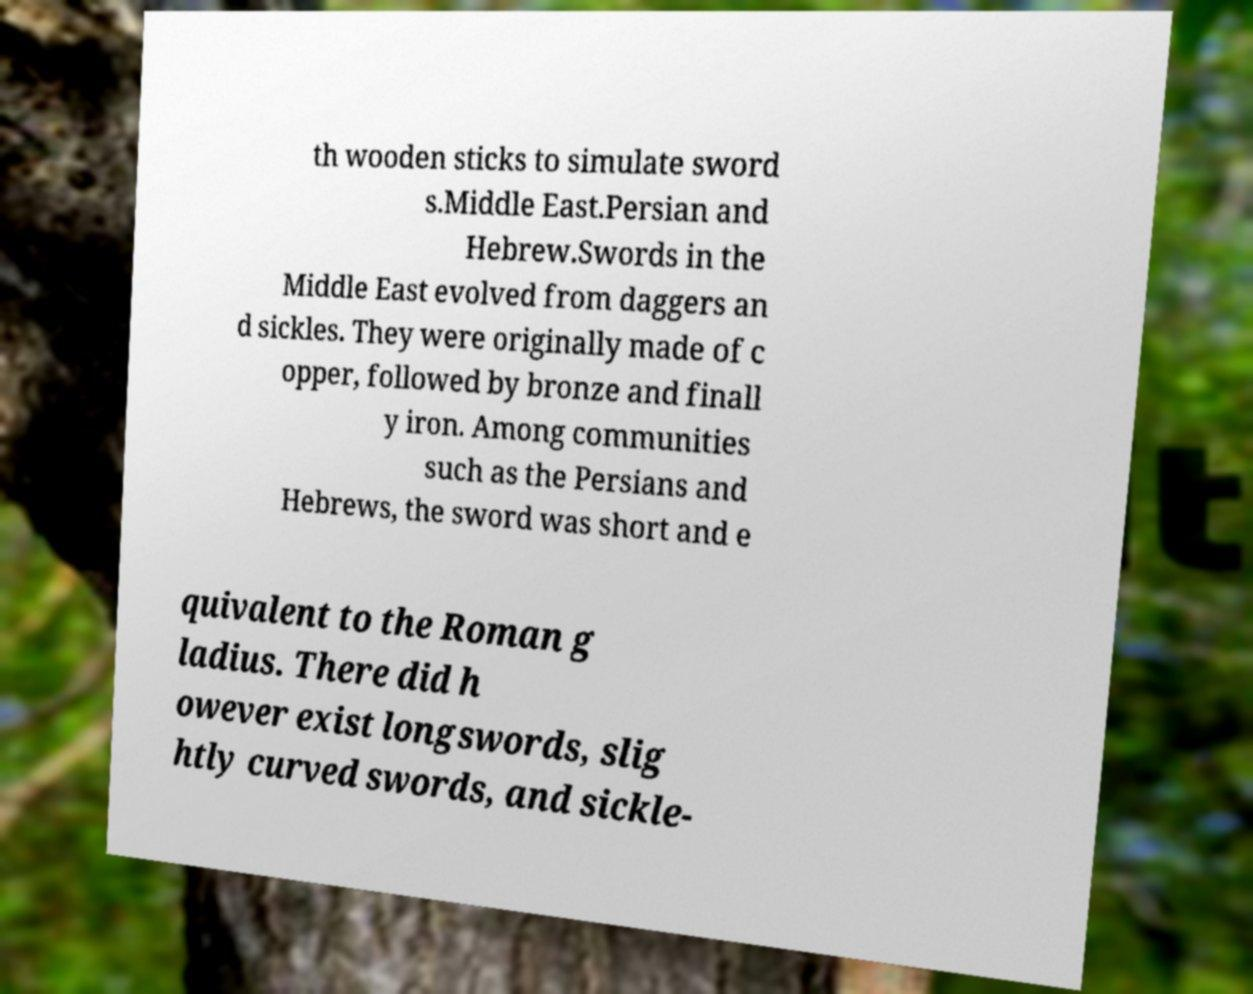There's text embedded in this image that I need extracted. Can you transcribe it verbatim? th wooden sticks to simulate sword s.Middle East.Persian and Hebrew.Swords in the Middle East evolved from daggers an d sickles. They were originally made of c opper, followed by bronze and finall y iron. Among communities such as the Persians and Hebrews, the sword was short and e quivalent to the Roman g ladius. There did h owever exist longswords, slig htly curved swords, and sickle- 